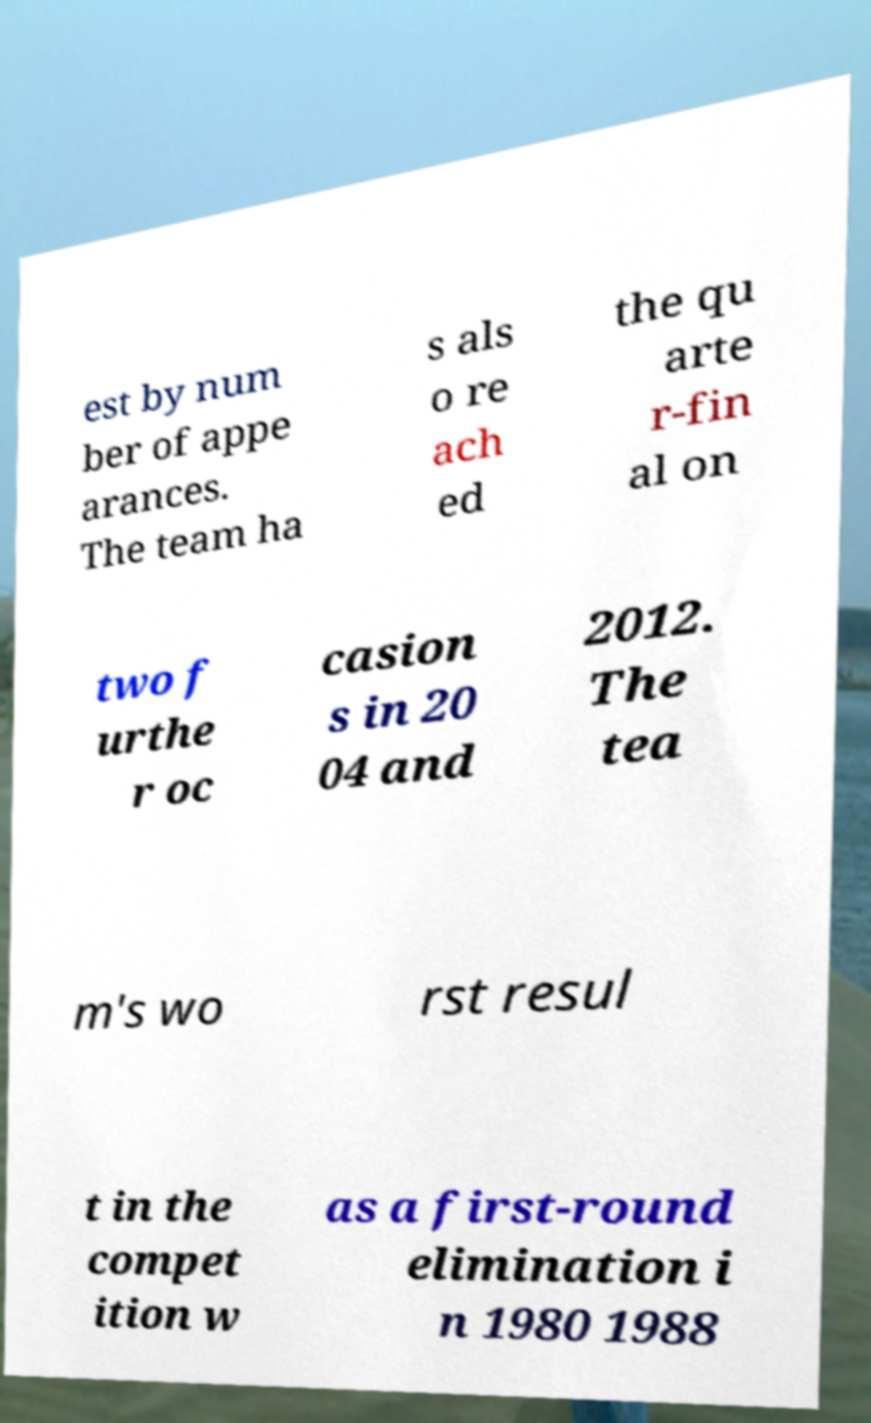I need the written content from this picture converted into text. Can you do that? est by num ber of appe arances. The team ha s als o re ach ed the qu arte r-fin al on two f urthe r oc casion s in 20 04 and 2012. The tea m's wo rst resul t in the compet ition w as a first-round elimination i n 1980 1988 